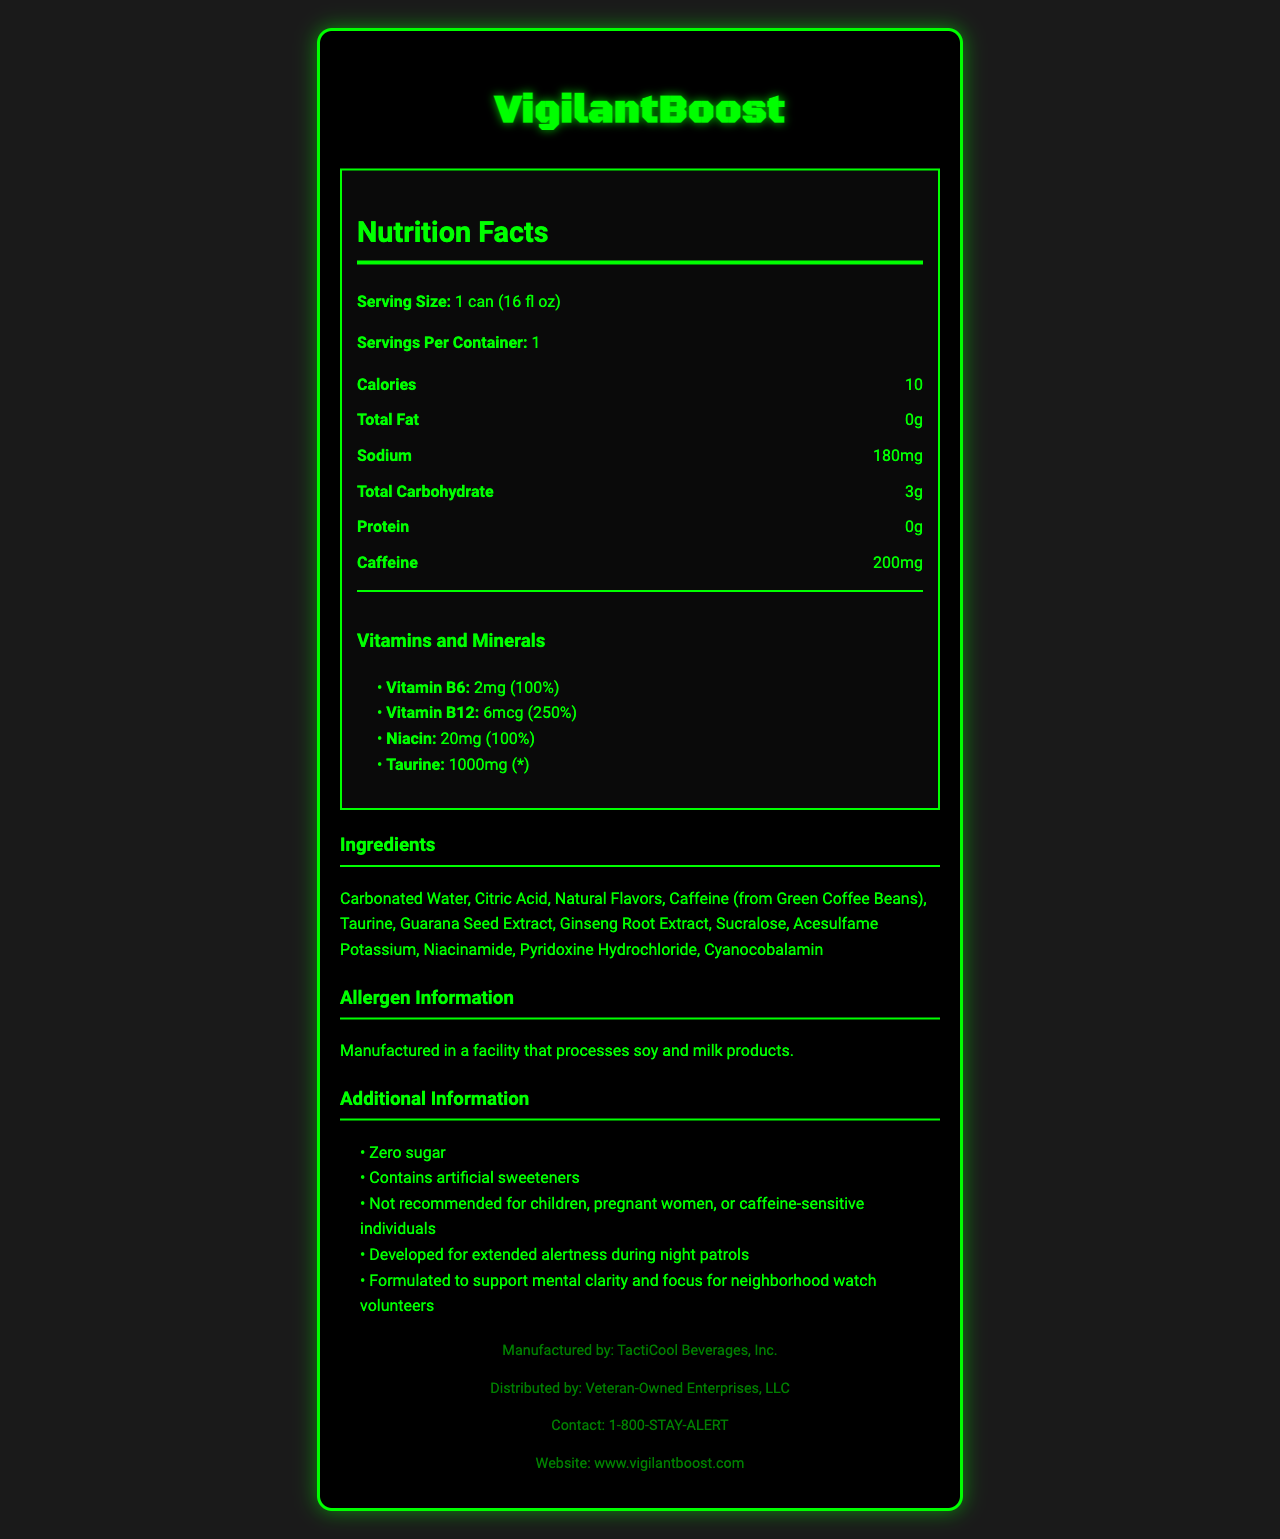what is the serving size? The serving size is indicated as "1 can (16 fl oz)" in the nutrition facts section.
Answer: 1 can (16 fl oz) how many calories are in one serving of VigilantBoost? The calories are listed as 10 in the nutrition facts section.
Answer: 10 what is the total fat content in this drink? The total fat content is stated as "0g" in the nutrition facts section.
Answer: 0g how much caffeine is in one can of VigilantBoost? The document states that each can contains "200mg" of caffeine.
Answer: 200mg list two ingredients found in VigilantBoost. The ingredients section lists all ingredients, and two of them are "Carbonated Water" and "Citric Acid."
Answer: Carbonated Water, Citric Acid how many servings per container? The document lists the servings per container as "1."
Answer: 1 what is the daily value percentage of Vitamin B12? The vitamins and minerals section lists the daily value percentage of Vitamin B12 as "250%."
Answer: 250% which of these ingredients is an artificial sweetener? A. Sucralose B. Ginseng Root Extract C. Taurine D. Niacinamide Sucralose is a known artificial sweetener; it is listed under the ingredients section.
Answer: A. Sucralose VigilantBoost is recommended for which group of individuals? A. Children B. Pregnant Women C. Caffeine-sensitive Individuals D. Neighborhood Watch Volunteers The additional info section states that the drink is formulated for neighborhood watch volunteers.
Answer: D. Neighborhood Watch Volunteers is this product suitable for people with soy allergies? The allergen info states that it is manufactured in a facility that processes soy, indicating potential contamination.
Answer: No does this product contain any sugar? The additional info section clearly states "Zero sugar."
Answer: No summarize the main purpose of VigilantBoost. The summary captures the key points given in the additional information and the primary ingredients aimed at providing alertness and focus.
Answer: VigilantBoost is a sugar-free energy drink designed to provide extended alertness and mental clarity, specifically formulated to support neighborhood watch volunteers during night patrols. It contains caffeine, vitamins, and minerals to enhance focus. why should pregnant women avoid this drink? The document does not provide a specific reason why pregnant women should avoid it; it just states they should in the additional information section.
Answer: Not enough information 